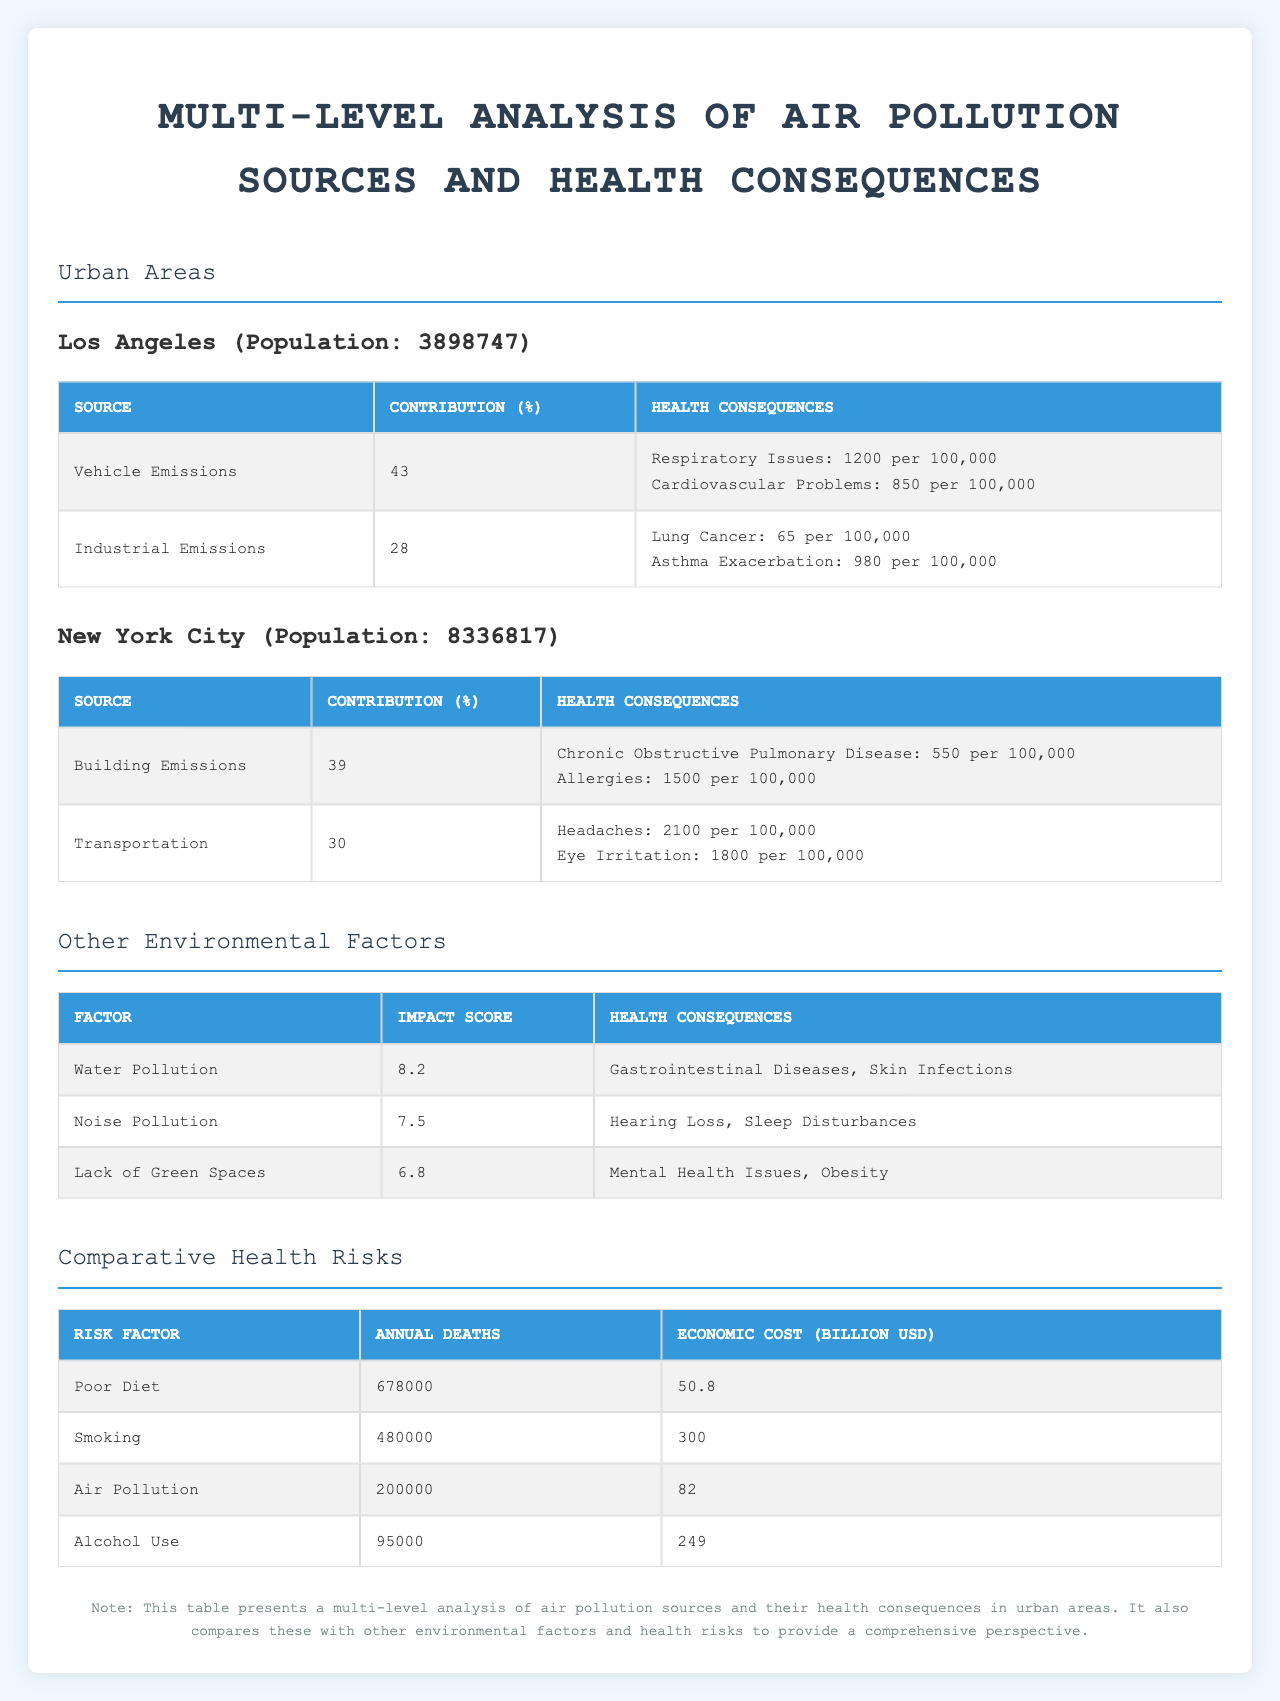What is the main source of air pollution in Los Angeles? The table shows that the major air pollution source in Los Angeles is Vehicle Emissions, which contributes 43% to air pollution.
Answer: Vehicle Emissions How many health consequences are linked to Industrial Emissions in Los Angeles? The table states that Industrial Emissions are associated with two health consequences: Lung Cancer and Asthma Exacerbation.
Answer: 2 Which city has a higher incidence of headaches due to air pollution? According to the table, New York City has an incidence rate of 2100 headaches per 100,000 due to Transportation, while Los Angeles does not list headaches among its health consequences.
Answer: New York City What is the cumulative contribution percentage of air pollution sources in New York City? The contributions from Building Emissions (39%) and Transportation (30%) add up to 69%.
Answer: 69% Is the incidence rate of allergies in New York City higher or lower than the incidence rate of respiratory issues in Los Angeles? The incidence rate of allergies in New York City is 1500 per 100,000, while respiratory issues in Los Angeles have an incidence rate of 1200 per 100,000. Therefore, allergies are higher.
Answer: Higher What is the total annual death count attributed to air pollution and poor diet combined? The table states that air pollution causes 200,000 deaths and poor diet causes 678,000 deaths. Adding these gives 200,000 + 678,000 = 878,000 annual deaths.
Answer: 878,000 Which risk factor has the highest economic cost according to the table? The table lists Smoking as the risk factor with the highest economic cost at 300 billion USD.
Answer: Smoking How many health consequences does the lack of green spaces have, according to the data? The data states that Lack of Green Spaces is associated with two health consequences: Mental Health Issues and Obesity.
Answer: 2 What is the impact score of noise pollution? The table indicates that the impact score of noise pollution is 7.5.
Answer: 7.5 What is the difference in annual deaths between Smoking and Alcohol Use? The table states Smoking causes 480,000 annual deaths, and Alcohol Use causes 95,000 annual deaths. The difference is 480,000 - 95,000 = 385,000.
Answer: 385,000 Which air pollution source has the lowest contribution percentage in Los Angeles? In Los Angeles, the air pollution source with the lowest contribution percentage is Industrial Emissions at 28%.
Answer: Industrial Emissions 